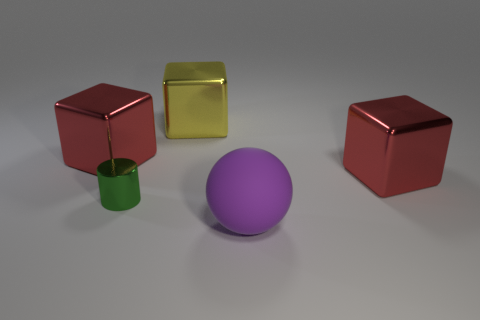Subtract all big yellow cubes. How many cubes are left? 2 Add 2 large shiny things. How many objects exist? 7 Subtract all red blocks. How many blocks are left? 1 Subtract all balls. How many objects are left? 4 Subtract 2 cubes. How many cubes are left? 1 Subtract all yellow rubber cubes. Subtract all green things. How many objects are left? 4 Add 3 large yellow cubes. How many large yellow cubes are left? 4 Add 3 large red objects. How many large red objects exist? 5 Subtract 0 red spheres. How many objects are left? 5 Subtract all purple cubes. Subtract all yellow cylinders. How many cubes are left? 3 